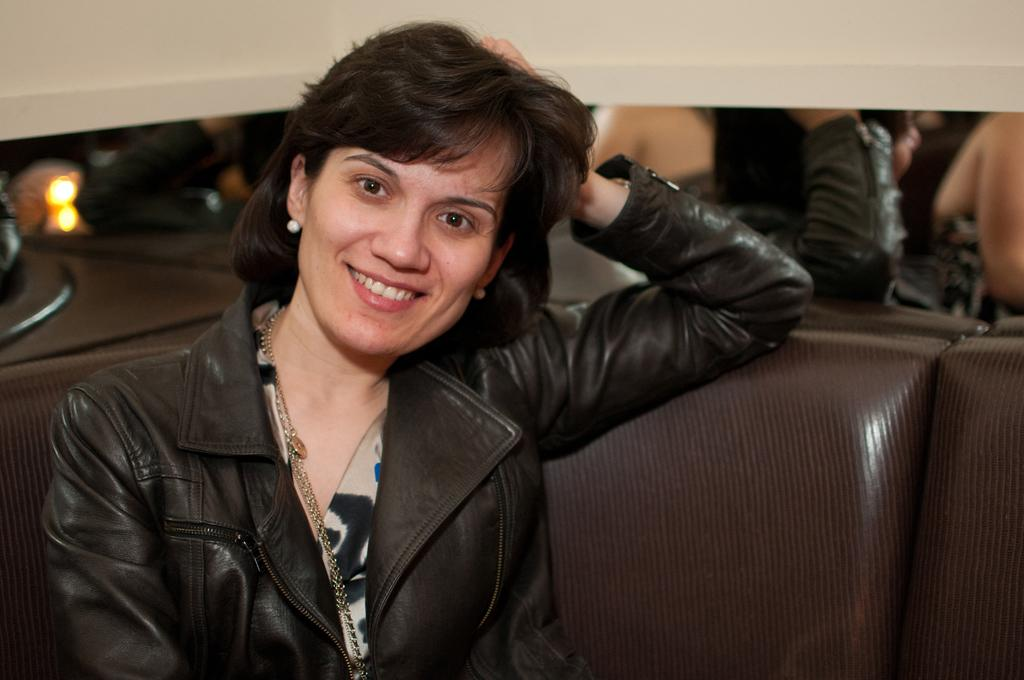What is the person in the image doing? There is a person sitting on the couch in the image. What can be seen on the wall in the background of the image? There is a mirror on the wall in the background of the image. How does the person in the image control the weather? The person in the image does not control the weather, as there is no indication of weather manipulation in the image. 